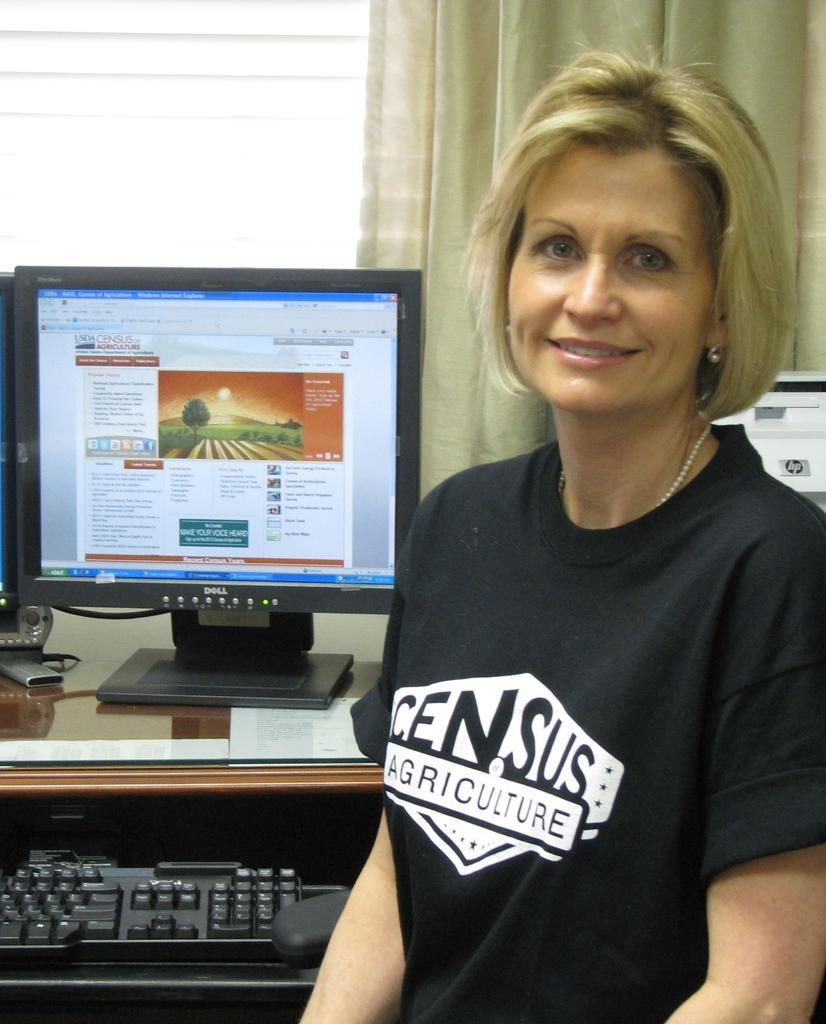Provide a one-sentence caption for the provided image. Web page USDA Census of Agriculture is pulled up on the Dell desktop. 